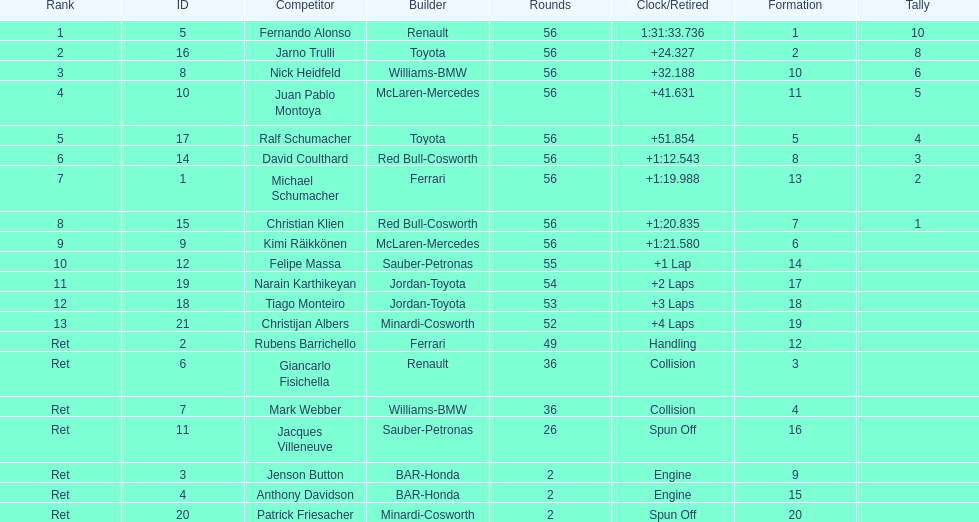Who was the last driver from the uk to actually finish the 56 laps? David Coulthard. 